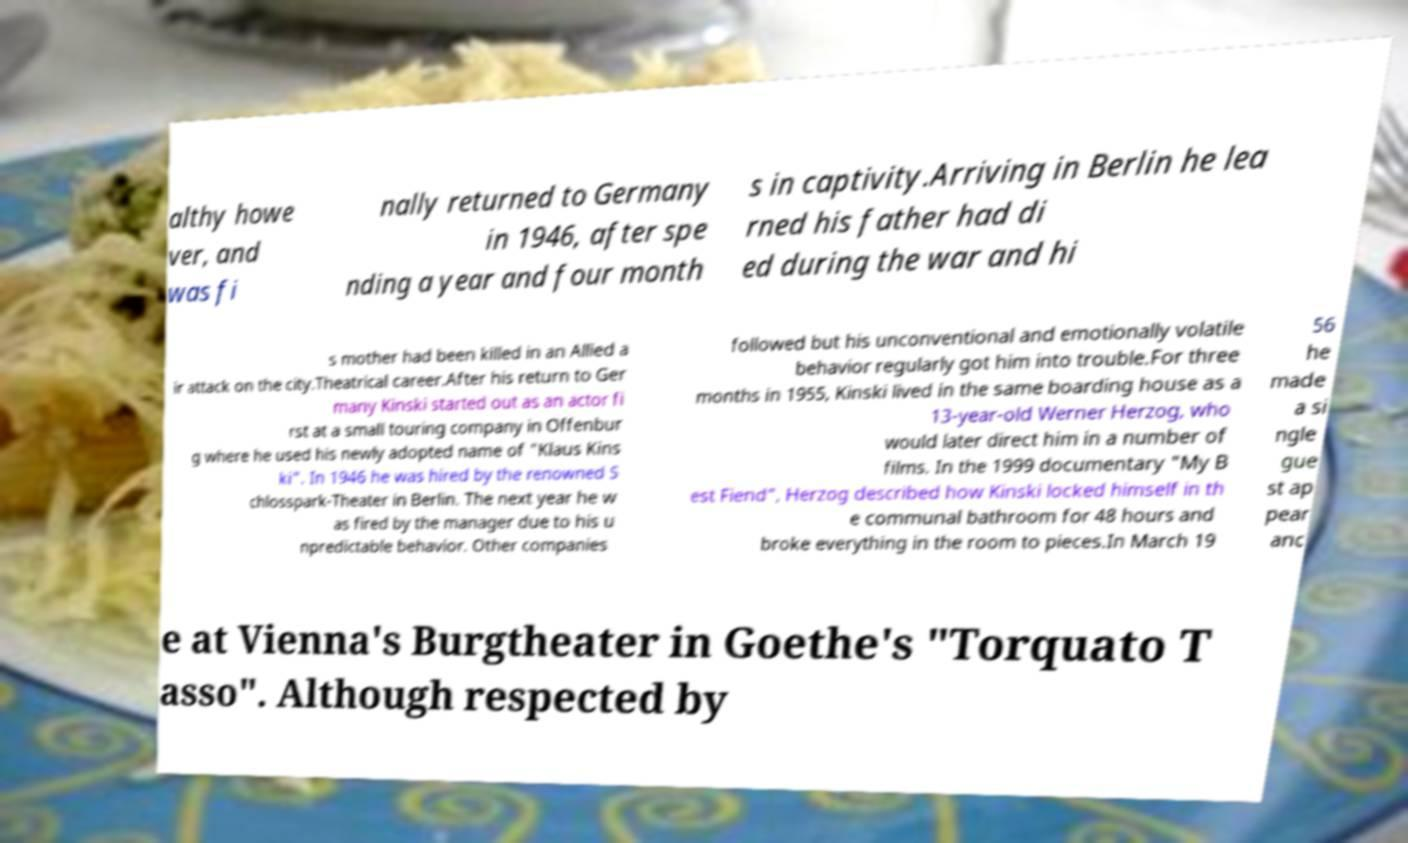Please read and relay the text visible in this image. What does it say? althy howe ver, and was fi nally returned to Germany in 1946, after spe nding a year and four month s in captivity.Arriving in Berlin he lea rned his father had di ed during the war and hi s mother had been killed in an Allied a ir attack on the city.Theatrical career.After his return to Ger many Kinski started out as an actor fi rst at a small touring company in Offenbur g where he used his newly adopted name of "Klaus Kins ki". In 1946 he was hired by the renowned S chlosspark-Theater in Berlin. The next year he w as fired by the manager due to his u npredictable behavior. Other companies followed but his unconventional and emotionally volatile behavior regularly got him into trouble.For three months in 1955, Kinski lived in the same boarding house as a 13-year-old Werner Herzog, who would later direct him in a number of films. In the 1999 documentary "My B est Fiend", Herzog described how Kinski locked himself in th e communal bathroom for 48 hours and broke everything in the room to pieces.In March 19 56 he made a si ngle gue st ap pear anc e at Vienna's Burgtheater in Goethe's "Torquato T asso". Although respected by 